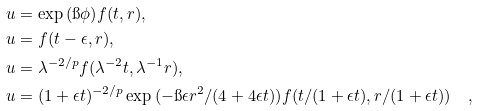<formula> <loc_0><loc_0><loc_500><loc_500>& u = \exp { ( \i \phi ) } f ( t , r ) , \\ & u = f ( t - \epsilon , r ) , \\ & u = \lambda ^ { - 2 / p } f ( \lambda ^ { - 2 } t , \lambda ^ { - 1 } r ) , \\ & u = ( 1 + \epsilon t ) ^ { - 2 / p } \exp { ( - \i \epsilon r ^ { 2 } / ( 4 + 4 \epsilon t ) ) } f ( t / ( 1 + \epsilon t ) , r / ( 1 + \epsilon t ) ) \quad ,</formula> 